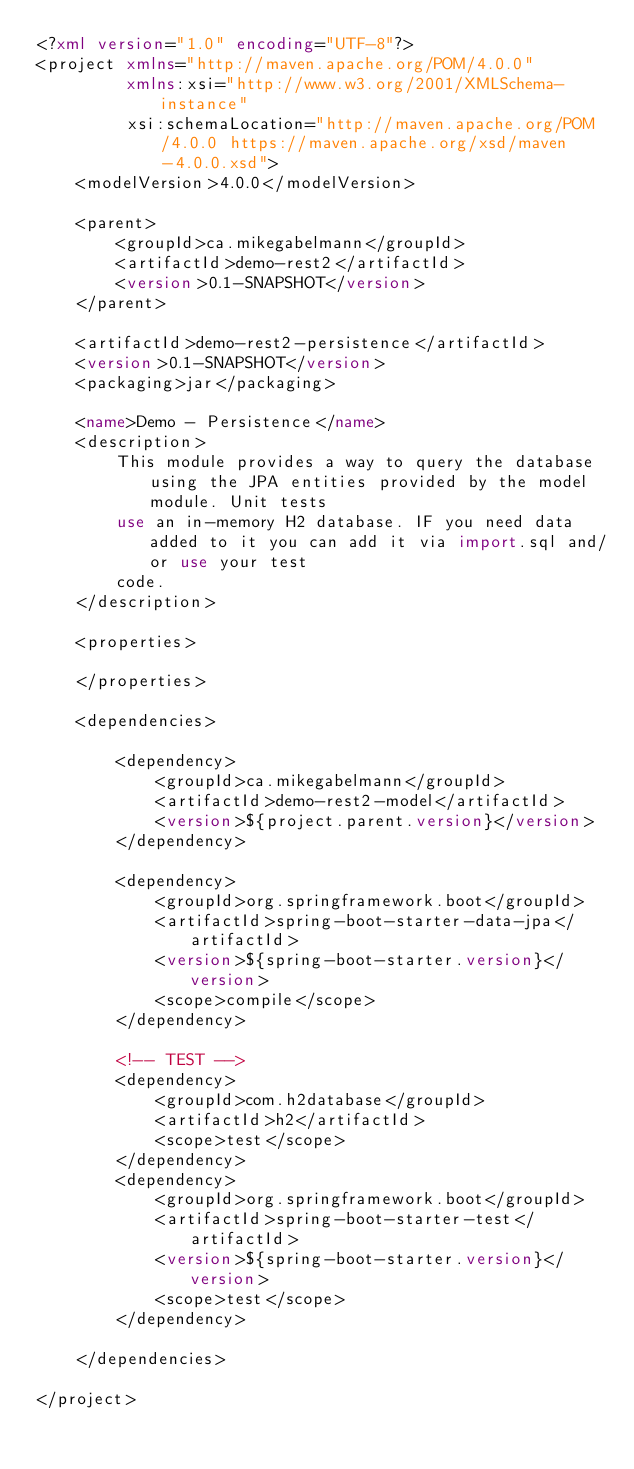<code> <loc_0><loc_0><loc_500><loc_500><_XML_><?xml version="1.0" encoding="UTF-8"?>
<project xmlns="http://maven.apache.org/POM/4.0.0"
         xmlns:xsi="http://www.w3.org/2001/XMLSchema-instance"
         xsi:schemaLocation="http://maven.apache.org/POM/4.0.0 https://maven.apache.org/xsd/maven-4.0.0.xsd">
    <modelVersion>4.0.0</modelVersion>

    <parent>
        <groupId>ca.mikegabelmann</groupId>
        <artifactId>demo-rest2</artifactId>
        <version>0.1-SNAPSHOT</version>
    </parent>

    <artifactId>demo-rest2-persistence</artifactId>
    <version>0.1-SNAPSHOT</version>
    <packaging>jar</packaging>

    <name>Demo - Persistence</name>
    <description>
        This module provides a way to query the database using the JPA entities provided by the model module. Unit tests
        use an in-memory H2 database. IF you need data added to it you can add it via import.sql and/or use your test
        code.
    </description>

    <properties>

    </properties>

    <dependencies>

        <dependency>
            <groupId>ca.mikegabelmann</groupId>
            <artifactId>demo-rest2-model</artifactId>
            <version>${project.parent.version}</version>
        </dependency>

        <dependency>
            <groupId>org.springframework.boot</groupId>
            <artifactId>spring-boot-starter-data-jpa</artifactId>
            <version>${spring-boot-starter.version}</version>
            <scope>compile</scope>
        </dependency>

        <!-- TEST -->
        <dependency>
            <groupId>com.h2database</groupId>
            <artifactId>h2</artifactId>
            <scope>test</scope>
        </dependency>
        <dependency>
            <groupId>org.springframework.boot</groupId>
            <artifactId>spring-boot-starter-test</artifactId>
            <version>${spring-boot-starter.version}</version>
            <scope>test</scope>
        </dependency>

    </dependencies>

</project>
</code> 